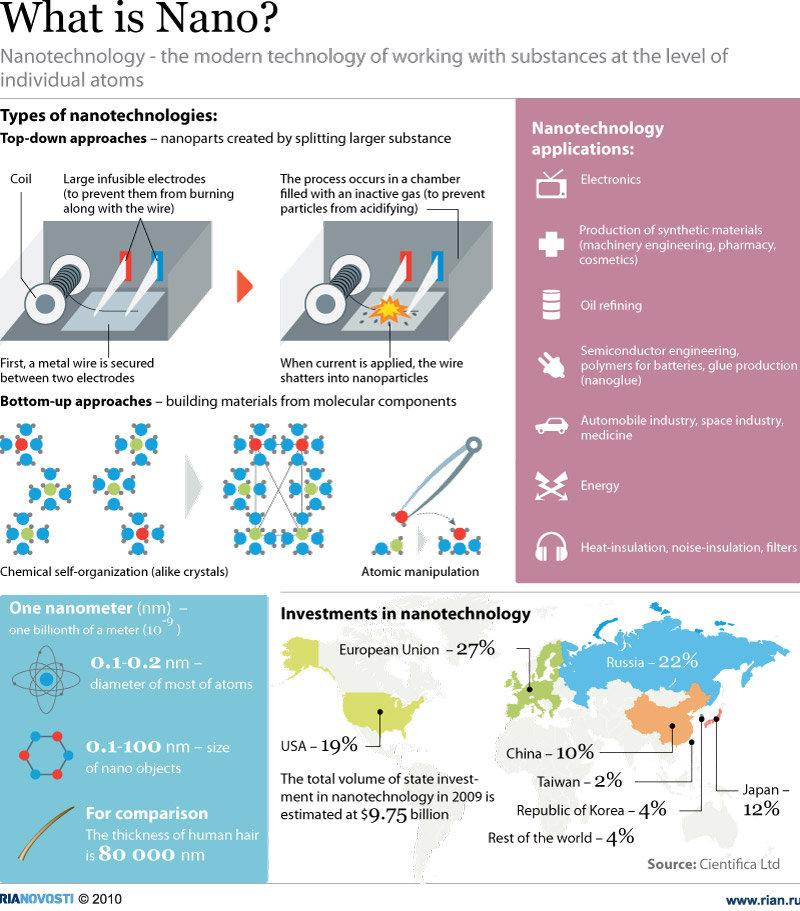Outline some significant characteristics in this image. According to the latest data, the investment by the Republic of Korea has reached equal levels with the rest of the world. Nanotechnology is a field of science and engineering that deals with the manipulation of matter at the nanoscale, which is typically defined as materials or structures that are between 1 and 100 nanometers in size. One example of a nanotechnology application is the use of nanoparticles in television screens to improve their performance. Specifically, electronics applications of nanotechnology could include the use of nanoparticles in displays, solar cells, or other electronic components. The ear phone icon represents a nanotechnology application that showcases heat-insulation, noise-insulation, and filtration properties. Russia has invested significantly less than the United States when comparing the amount of investment in renewable energy technology. Other than top-down approaches, there is another type of nanotechnology known as bottom-up approaches. 